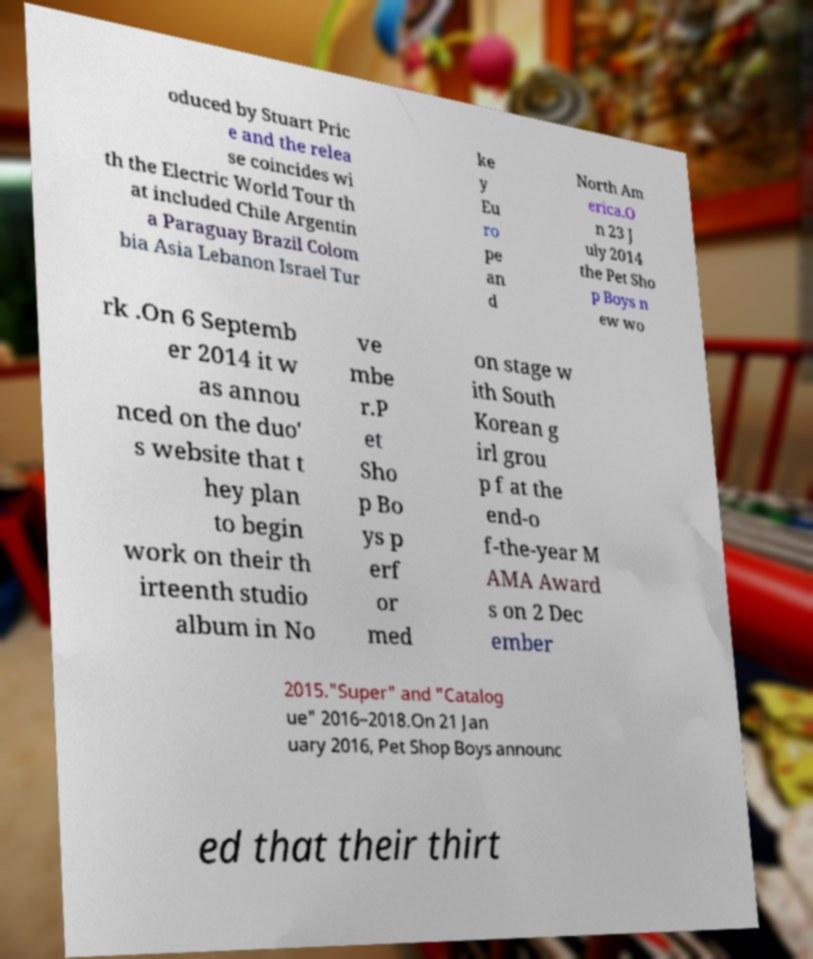What messages or text are displayed in this image? I need them in a readable, typed format. oduced by Stuart Pric e and the relea se coincides wi th the Electric World Tour th at included Chile Argentin a Paraguay Brazil Colom bia Asia Lebanon Israel Tur ke y Eu ro pe an d North Am erica.O n 23 J uly 2014 the Pet Sho p Boys n ew wo rk .On 6 Septemb er 2014 it w as annou nced on the duo' s website that t hey plan to begin work on their th irteenth studio album in No ve mbe r.P et Sho p Bo ys p erf or med on stage w ith South Korean g irl grou p f at the end-o f-the-year M AMA Award s on 2 Dec ember 2015."Super" and "Catalog ue" 2016–2018.On 21 Jan uary 2016, Pet Shop Boys announc ed that their thirt 